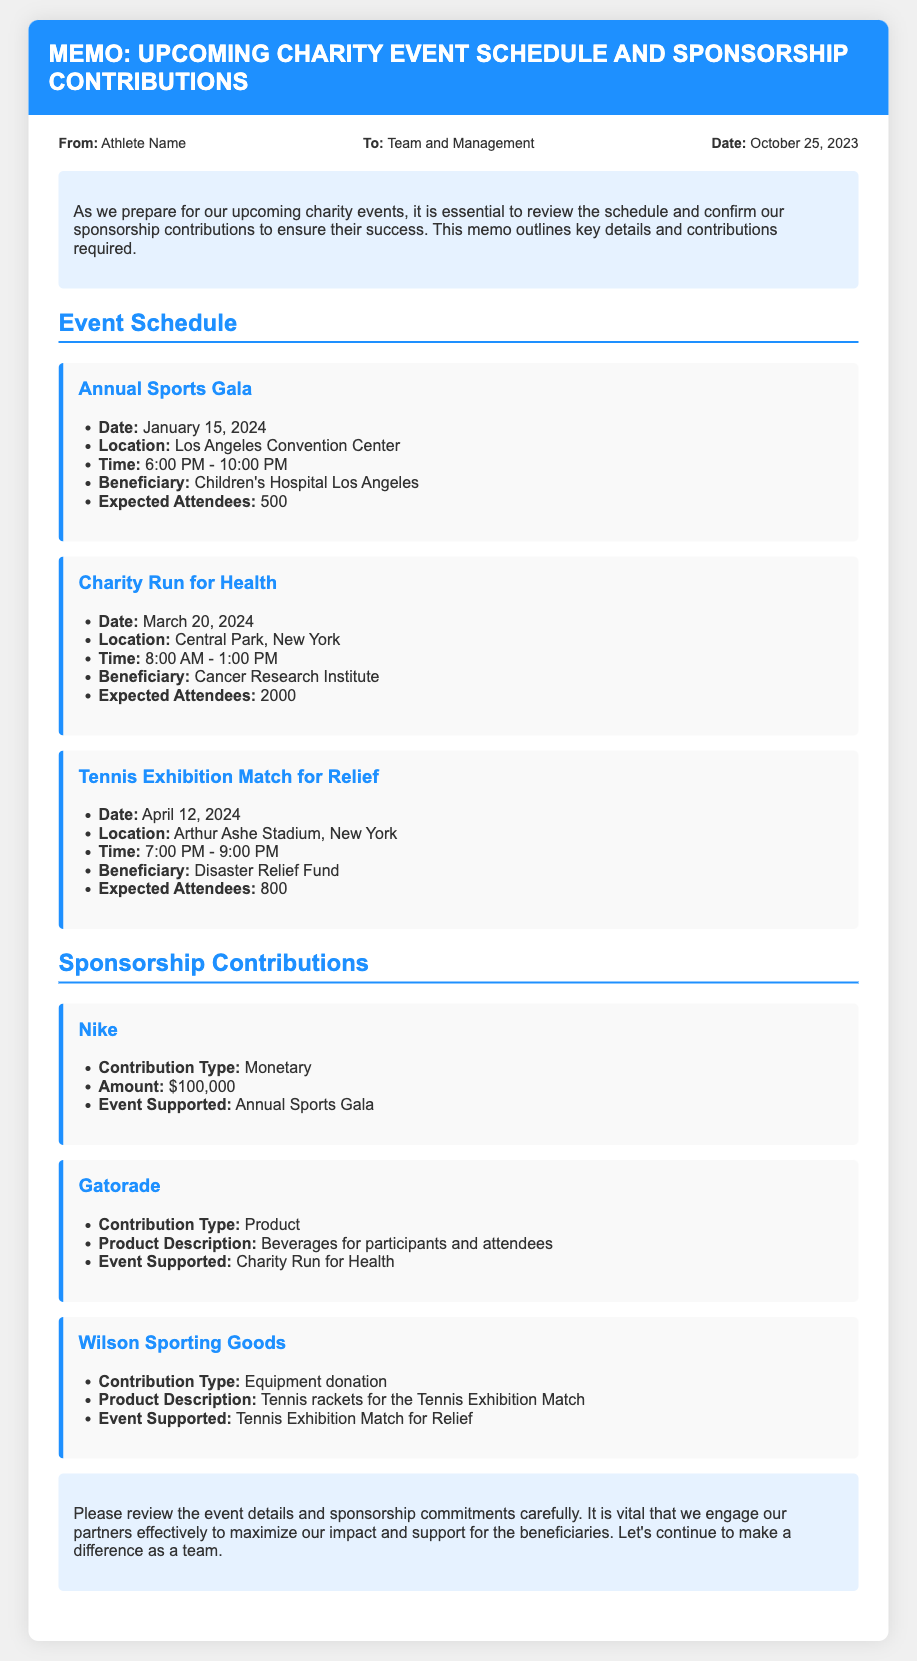what is the date of the Annual Sports Gala? The date for the Annual Sports Gala is specified in the event schedule.
Answer: January 15, 2024 where is the Charity Run for Health taking place? The location for the Charity Run for Health is provided in the event details.
Answer: Central Park, New York who is the beneficiary of the Tennis Exhibition Match for Relief? The beneficiary for the Tennis Exhibition Match can be found in the event information.
Answer: Disaster Relief Fund how much is Nike contributing? The contribution amount from Nike is listed under sponsorship contributions.
Answer: $100,000 what is Gatorade contributing for the Charity Run for Health? The type of contribution from Gatorade is specified in the sponsorship section related to the event.
Answer: Product which event has the highest expected attendees? The expected attendees for each event can be compared in the schedule.
Answer: Charity Run for Health how many events are listed in the memo? The total number of events can be counted from the event schedule section.
Answer: 3 who is sending the memo? The sender's name is provided in the meta section of the document.
Answer: Athlete Name what type of contribution is Wilson Sporting Goods making? The contribution type for Wilson Sporting Goods is specified in the sponsorship contributions.
Answer: Equipment donation 